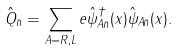Convert formula to latex. <formula><loc_0><loc_0><loc_500><loc_500>\hat { Q } _ { \bar { n } } = \sum _ { A = R , L } e \hat { \psi } ^ { \dag } _ { A \bar { n } } ( x ) \hat { \psi } _ { A \bar { n } } ( x ) .</formula> 